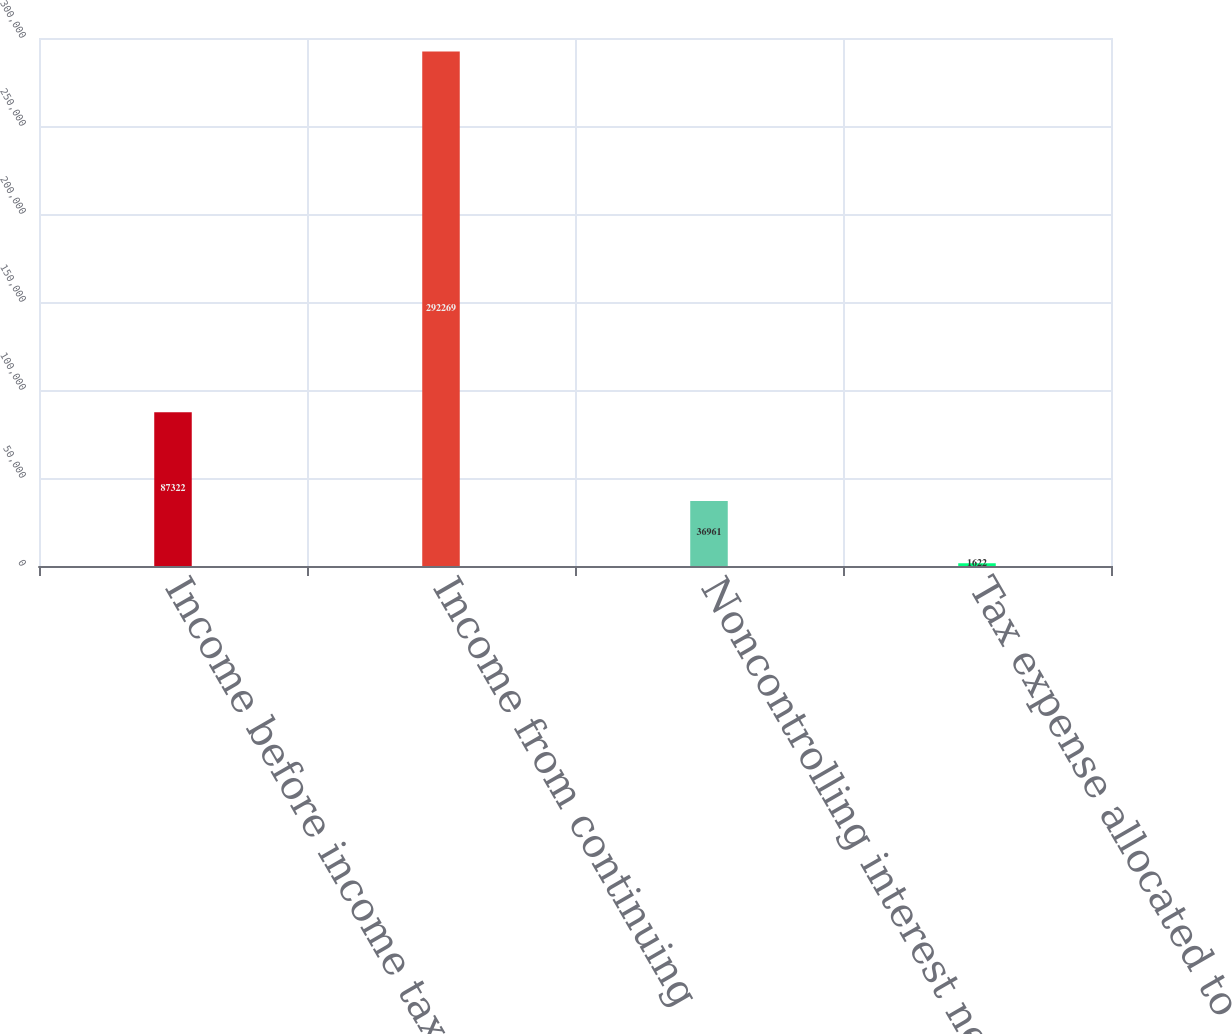Convert chart. <chart><loc_0><loc_0><loc_500><loc_500><bar_chart><fcel>Income before income taxes and<fcel>Income from continuing<fcel>Noncontrolling interest net of<fcel>Tax expense allocated to<nl><fcel>87322<fcel>292269<fcel>36961<fcel>1622<nl></chart> 